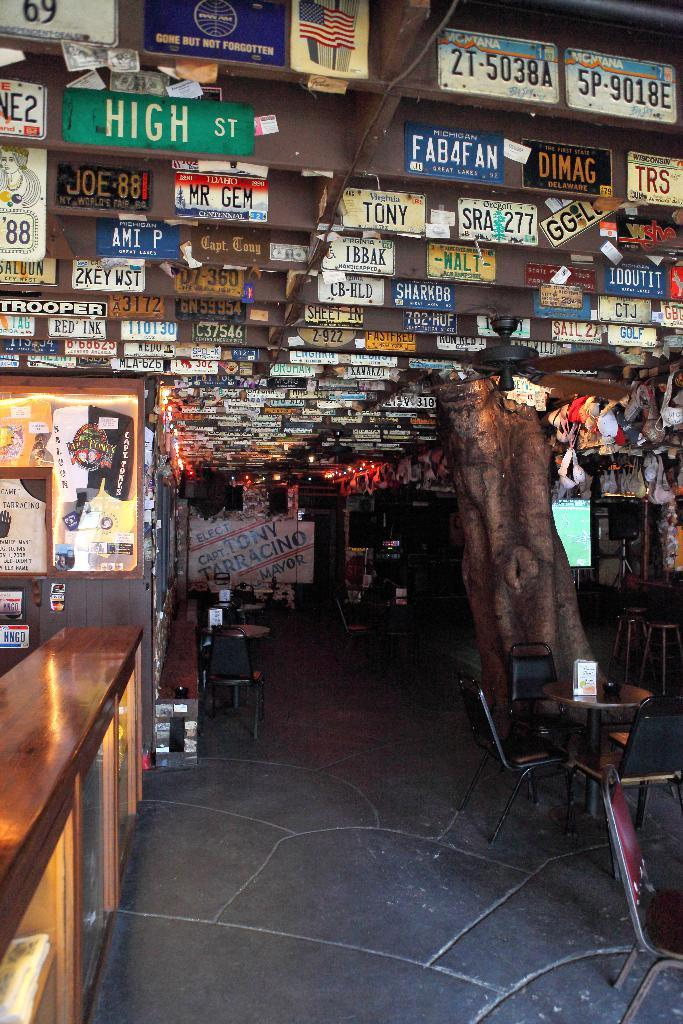<image>
Provide a brief description of the given image. Many signs are in this establishment, including one that says High St. 